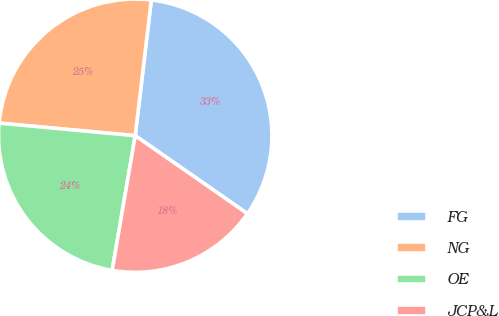Convert chart. <chart><loc_0><loc_0><loc_500><loc_500><pie_chart><fcel>FG<fcel>NG<fcel>OE<fcel>JCP&L<nl><fcel>32.79%<fcel>25.41%<fcel>23.77%<fcel>18.03%<nl></chart> 